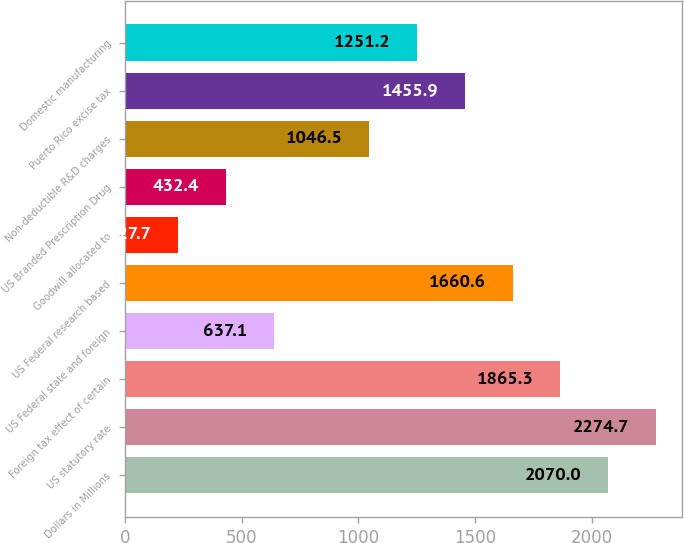<chart> <loc_0><loc_0><loc_500><loc_500><bar_chart><fcel>Dollars in Millions<fcel>US statutory rate<fcel>Foreign tax effect of certain<fcel>US Federal state and foreign<fcel>US Federal research based<fcel>Goodwill allocated to<fcel>US Branded Prescription Drug<fcel>Non-deductible R&D charges<fcel>Puerto Rico excise tax<fcel>Domestic manufacturing<nl><fcel>2070<fcel>2274.7<fcel>1865.3<fcel>637.1<fcel>1660.6<fcel>227.7<fcel>432.4<fcel>1046.5<fcel>1455.9<fcel>1251.2<nl></chart> 